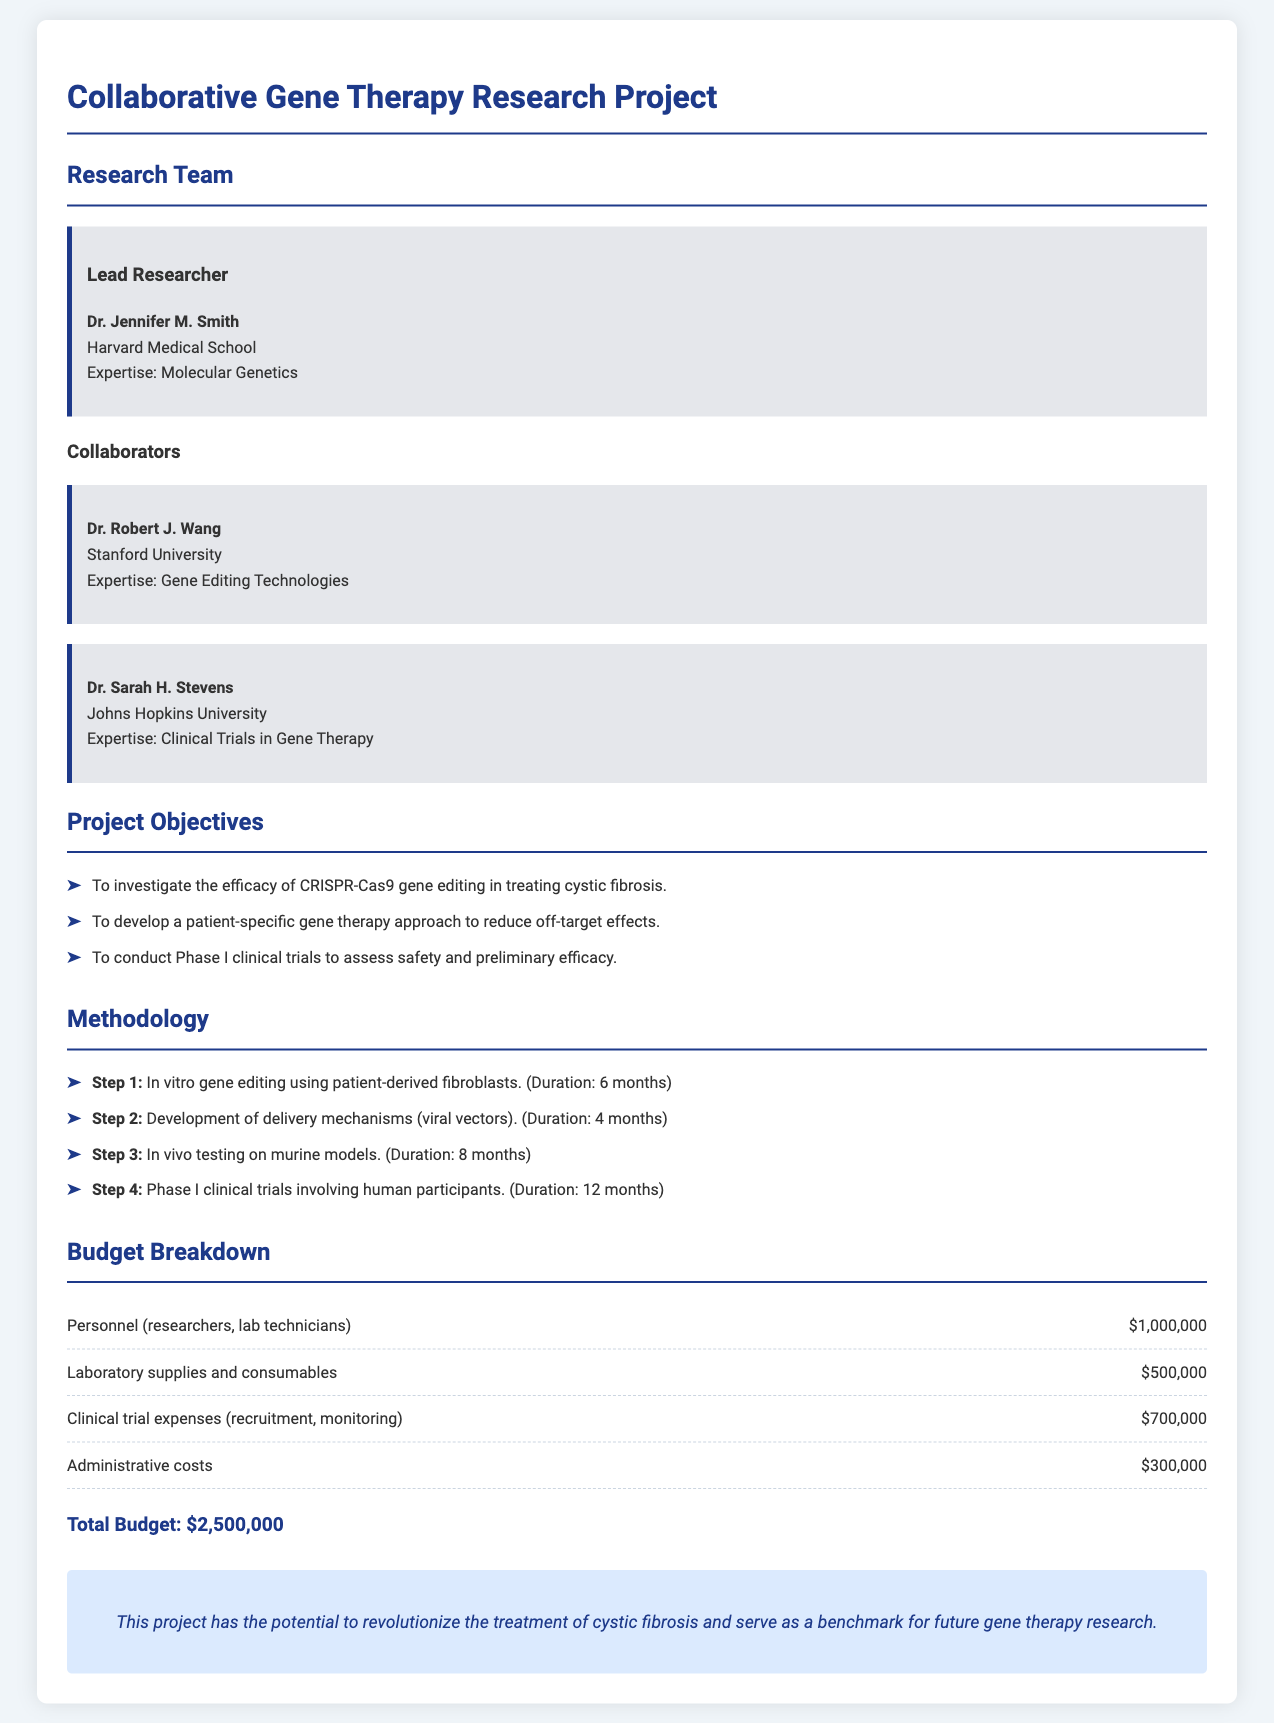What is the name of the lead researcher? The lead researcher is specifically mentioned as Dr. Jennifer M. Smith in the document.
Answer: Dr. Jennifer M. Smith What is the primary objective of the project? One of the main objectives listed in the project is to investigate the efficacy of CRISPR-Cas9 gene editing in treating cystic fibrosis.
Answer: Investigate the efficacy of CRISPR-Cas9 gene editing in treating cystic fibrosis How long will the in vitro gene editing step take? The duration of the in vitro gene editing step is specified in the document as 6 months.
Answer: 6 months What is the total budget for the project? The total budget is clearly stated in a dedicated section of the document and amounts to $2,500,000.
Answer: $2,500,000 Which university does Dr. Robert J. Wang belong to? His affiliation is mentioned in the document as Stanford University.
Answer: Stanford University What is the duration of the Phase I clinical trials? The duration of this clinical trial phase is explicitly mentioned as 12 months.
Answer: 12 months What type of technology is being investigated in the project? The document indicates that gene editing technologies, particularly CRISPR-Cas9, are being investigated.
Answer: Gene editing technologies What is the focus of the clinical trials mentioned? The focus of the clinical trials is to assess safety and preliminary efficacy, as stated in the objectives section.
Answer: Assess safety and preliminary efficacy 